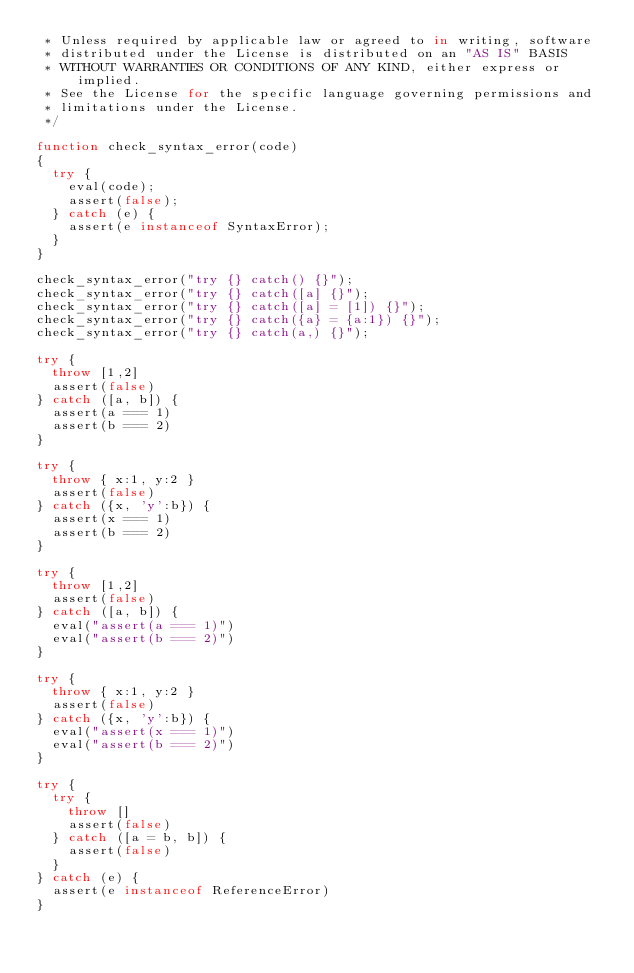Convert code to text. <code><loc_0><loc_0><loc_500><loc_500><_JavaScript_> * Unless required by applicable law or agreed to in writing, software
 * distributed under the License is distributed on an "AS IS" BASIS
 * WITHOUT WARRANTIES OR CONDITIONS OF ANY KIND, either express or implied.
 * See the License for the specific language governing permissions and
 * limitations under the License.
 */

function check_syntax_error(code)
{
  try {
    eval(code);
    assert(false);
  } catch (e) {
    assert(e instanceof SyntaxError);
  }
}

check_syntax_error("try {} catch() {}");
check_syntax_error("try {} catch([a] {}");
check_syntax_error("try {} catch([a] = [1]) {}");
check_syntax_error("try {} catch({a} = {a:1}) {}");
check_syntax_error("try {} catch(a,) {}");

try {
  throw [1,2]
  assert(false)
} catch ([a, b]) {
  assert(a === 1)
  assert(b === 2)
}

try {
  throw { x:1, y:2 }
  assert(false)
} catch ({x, 'y':b}) {
  assert(x === 1)
  assert(b === 2)
}

try {
  throw [1,2]
  assert(false)
} catch ([a, b]) {
  eval("assert(a === 1)")
  eval("assert(b === 2)")
}

try {
  throw { x:1, y:2 }
  assert(false)
} catch ({x, 'y':b}) {
  eval("assert(x === 1)")
  eval("assert(b === 2)")
}

try {
  try {
    throw []
    assert(false)
  } catch ([a = b, b]) {
    assert(false)
  }
} catch (e) {
  assert(e instanceof ReferenceError)
}
</code> 